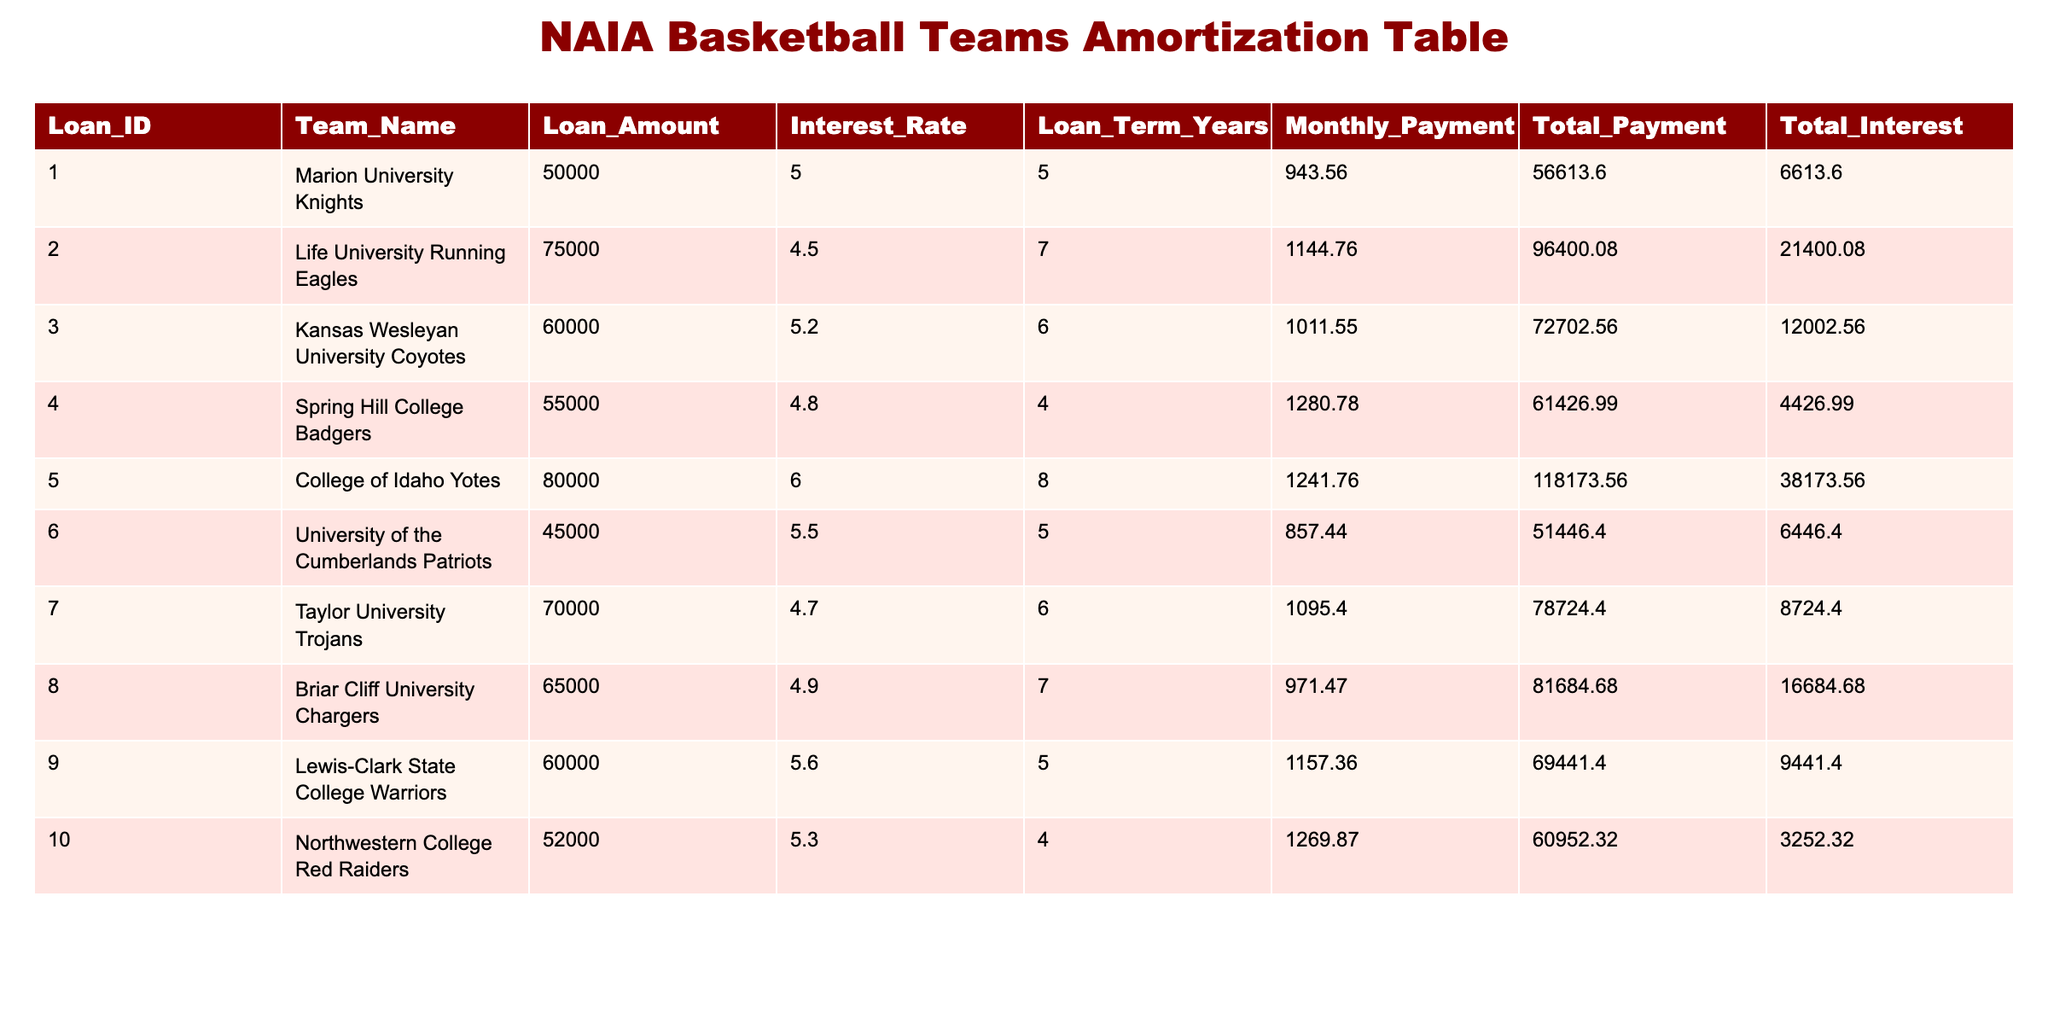What is the total loan amount for all teams combined? To find this, I will sum the values in the Loan_Amount column: 50000 + 75000 + 60000 + 55000 + 80000 + 45000 + 70000 + 65000 + 60000 + 52000 =  495000.
Answer: 495000 Which team has the highest interest rate on their loan? I will compare the interest rates in the Interest_Rate column and find that College of Idaho Yotes has the highest rate at 6.0.
Answer: College of Idaho Yotes What is the monthly payment for the Life University Running Eagles? The Monthly_Payment for Life University Running Eagles can be directly obtained from the table, which states it is 1144.76.
Answer: 1144.76 How much total interest will the Spring Hill College Badgers pay on their loan? The Total_Interest for Spring Hill College Badgers is listed in the table as 4426.99, which directly answers the question.
Answer: 4426.99 What is the average monthly payment for all teams? To find this, I will sum all monthly payments and divide by the number of teams. The sum is (943.56 + 1144.76 + 1011.55 + 1280.78 + 1241.76 + 857.44 + 1095.40 + 971.47 + 1157.36 + 1269.87) = 11482.98. There are 10 teams, so the average is 11482.98 / 10 = 1148.30.
Answer: 1148.30 Is it true that more than 5 teams have loan terms longer than 6 years? I will count the Loan_Term_Years column entries that are greater than 6. The teams are Life University Running Eagles (7), College of Idaho Yotes (8), and Briar Cliff University Chargers (7). Thus, only 3 teams have a loan term longer than 6 years, which is not more than 5.
Answer: No What is the difference in total payments between the highest and lowest loan amounts? First, I identify the total payments for the teams with the highest and lowest loan amounts. The highest loan amount belongs to College of Idaho Yotes with a total payment of 118173.56. The lowest loan amount belongs to University of the Cumberlands Patriots with a total payment of 51446.40. The difference is 118173.56 - 51446.40 = 66727.16.
Answer: 66727.16 How much total payment will the Kansas Wesleyan University Coyotes make over the term of their loan? The Total_Payment for Kansas Wesleyan University Coyotes is explicitly stated in the table as 72702.56.
Answer: 72702.56 Which team has the lowest total payment for their loan? I will look for the lowest value in the Total_Payment column. Spring Hill College Badgers has the lowest total payment at 61426.99.
Answer: Spring Hill College Badgers 